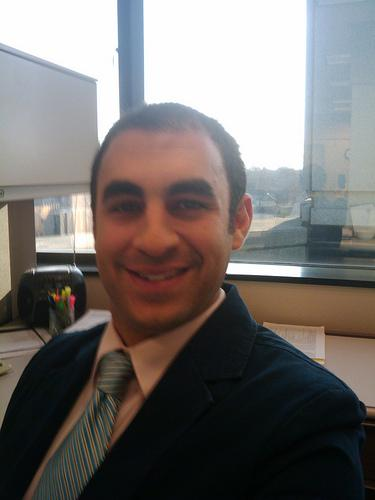Question: where is this picture taking place?
Choices:
A. A library.
B. A casino.
C. A restaurant.
D. An office.
Answer with the letter. Answer: D Question: what is the man wearing?
Choices:
A. A baseball uniform.
B. A t-shirt and jeans.
C. A pair of pink pajamas.
D. A suit and tie.
Answer with the letter. Answer: D Question: what is the primary color of the man's tie?
Choices:
A. Blue.
B. Red.
C. Green.
D. Black.
Answer with the letter. Answer: A Question: what facial expression is the man using?
Choices:
A. He is smiling.
B. He is frowning.
C. He is grimacing.
D. He is crying.
Answer with the letter. Answer: A 